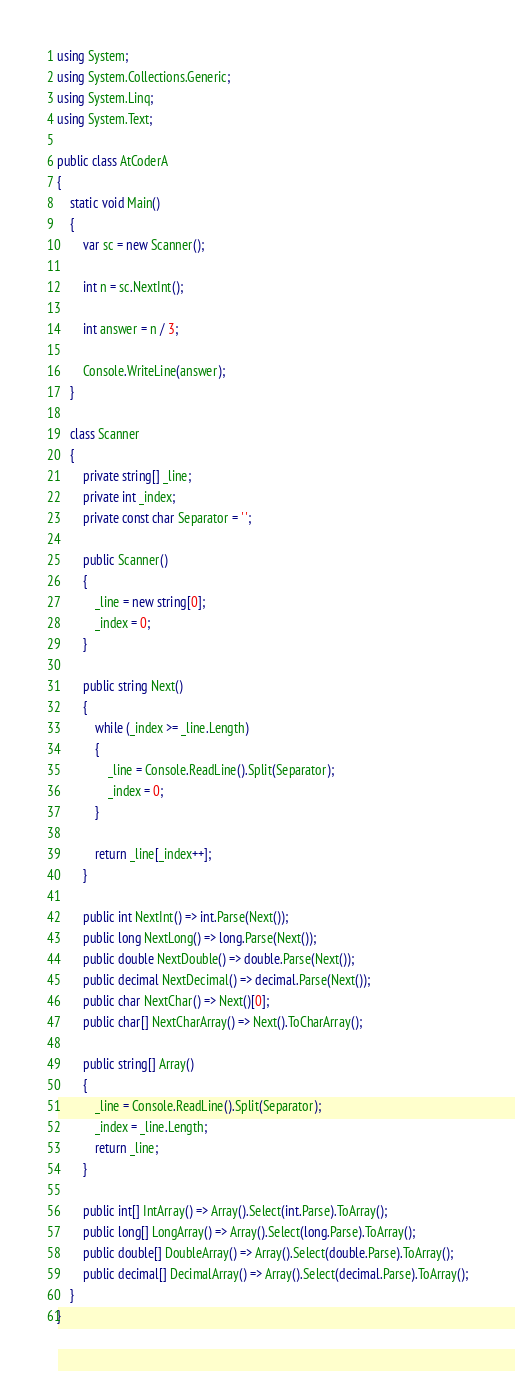Convert code to text. <code><loc_0><loc_0><loc_500><loc_500><_C#_>using System;
using System.Collections.Generic;
using System.Linq;
using System.Text;

public class AtCoderA
{
    static void Main()
    {
        var sc = new Scanner();

        int n = sc.NextInt();

        int answer = n / 3;

        Console.WriteLine(answer);
    }

    class Scanner
    {
        private string[] _line;
        private int _index;
        private const char Separator = ' ';

        public Scanner()
        {
            _line = new string[0];
            _index = 0;
        }

        public string Next()
        {
            while (_index >= _line.Length)
            {
                _line = Console.ReadLine().Split(Separator);
                _index = 0;
            }

            return _line[_index++];
        }

        public int NextInt() => int.Parse(Next());
        public long NextLong() => long.Parse(Next());
        public double NextDouble() => double.Parse(Next());
        public decimal NextDecimal() => decimal.Parse(Next());
        public char NextChar() => Next()[0];
        public char[] NextCharArray() => Next().ToCharArray();

        public string[] Array()
        {
            _line = Console.ReadLine().Split(Separator);
            _index = _line.Length;
            return _line;
        }

        public int[] IntArray() => Array().Select(int.Parse).ToArray();
        public long[] LongArray() => Array().Select(long.Parse).ToArray();
        public double[] DoubleArray() => Array().Select(double.Parse).ToArray();
        public decimal[] DecimalArray() => Array().Select(decimal.Parse).ToArray();
    }
}</code> 